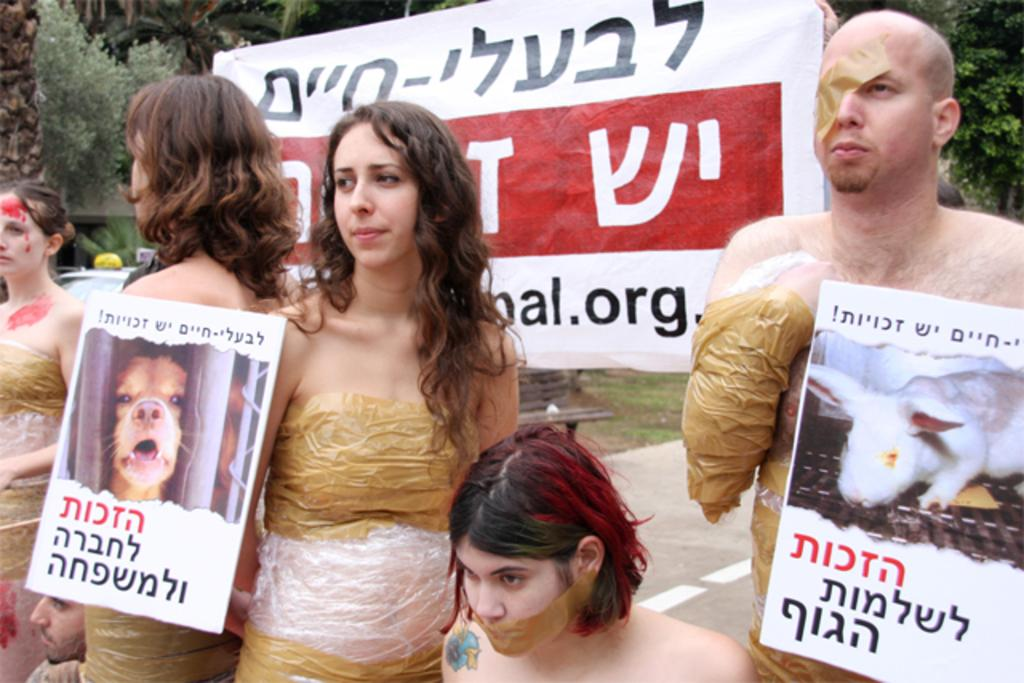What are the people in the image doing? The people in the image are standing and holding boards. What else can be seen in the image besides the people? There is a banner in the image. What type of natural elements are visible in the image? There are trees visible in the image. How many shoes can be seen on the people in the image? There is no information about shoes in the image, so we cannot determine how many shoes are visible. 